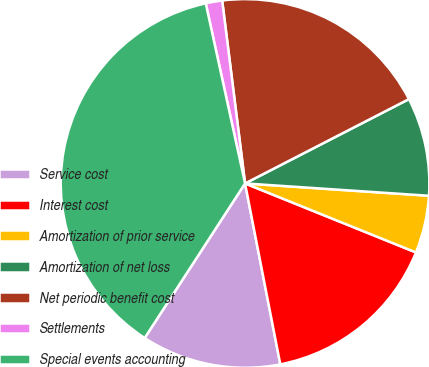<chart> <loc_0><loc_0><loc_500><loc_500><pie_chart><fcel>Service cost<fcel>Interest cost<fcel>Amortization of prior service<fcel>Amortization of net loss<fcel>Net periodic benefit cost<fcel>Settlements<fcel>Special events accounting<nl><fcel>12.23%<fcel>15.83%<fcel>5.04%<fcel>8.63%<fcel>19.42%<fcel>1.44%<fcel>37.41%<nl></chart> 